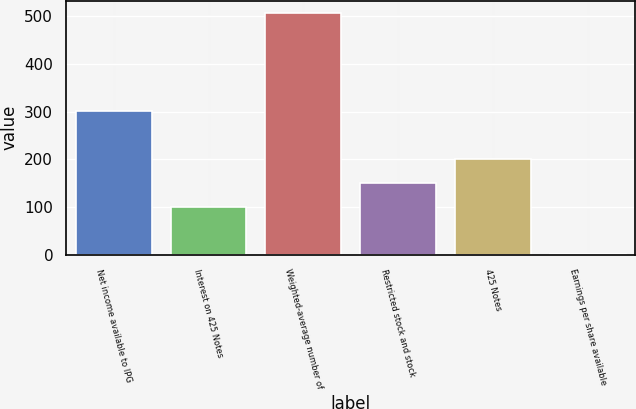Convert chart. <chart><loc_0><loc_0><loc_500><loc_500><bar_chart><fcel>Net income available to IPG<fcel>Interest on 425 Notes<fcel>Weighted-average number of<fcel>Restricted stock and stock<fcel>425 Notes<fcel>Earnings per share available<nl><fcel>301.94<fcel>100.82<fcel>507.98<fcel>151.1<fcel>201.38<fcel>0.26<nl></chart> 